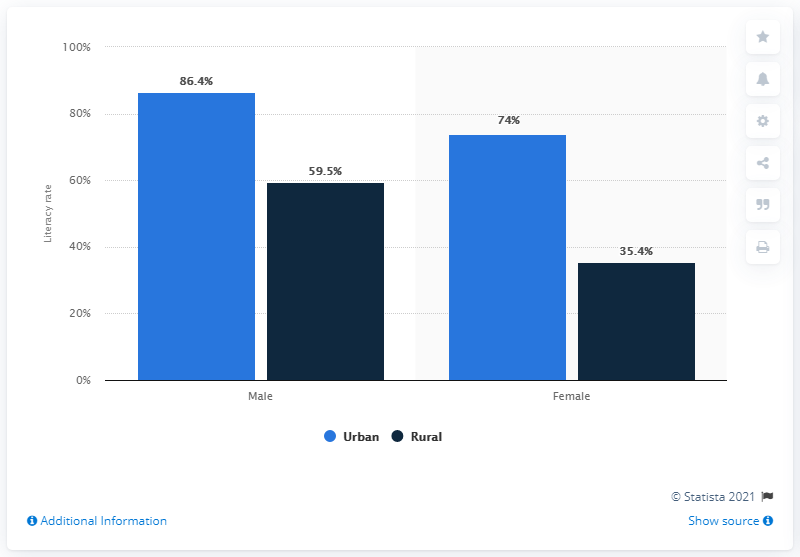Highlight a few significant elements in this photo. In 2018, the literacy rate among men living in rural areas of Nigeria was 59.5%. 